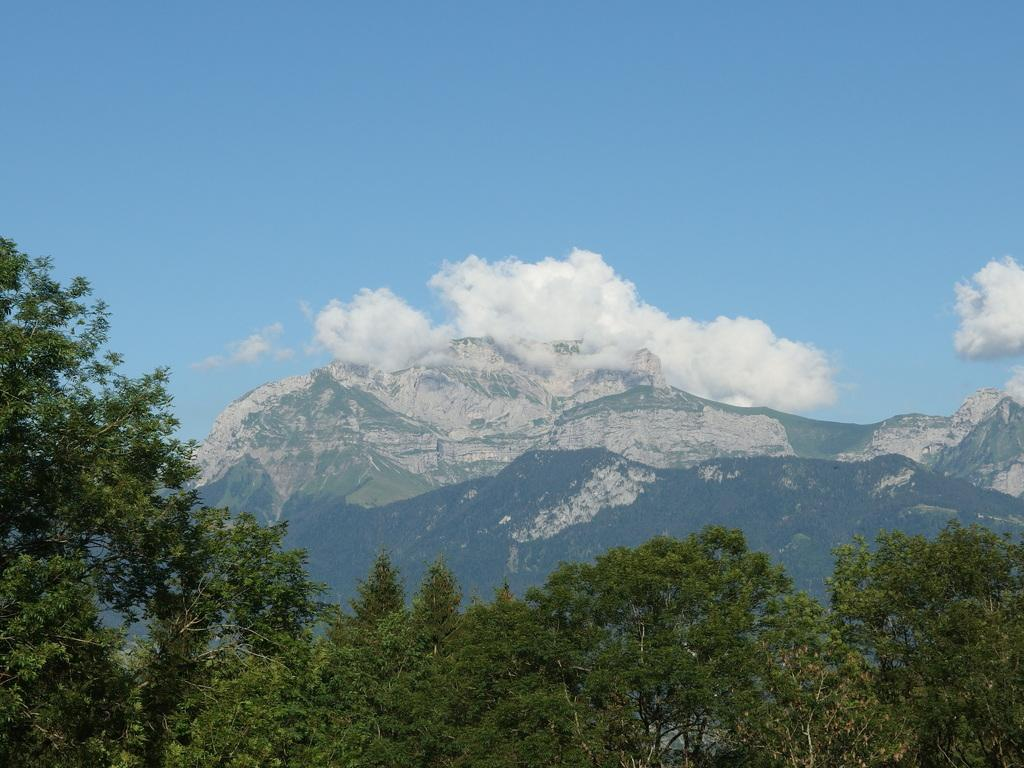Where was the picture taken? The picture was clicked outside the city. What can be seen in the foreground of the image? There are trees in the foreground of the image. What geographical feature is in the center of the image? There are hills in the center of the image. What is visible in the background of the image? The sky is visible in the background of the image. What can be observed in the sky? Clouds are present in the sky. What type of songs can be heard coming from the trees in the image? There are no sounds or songs present in the image, as it is a still photograph. 